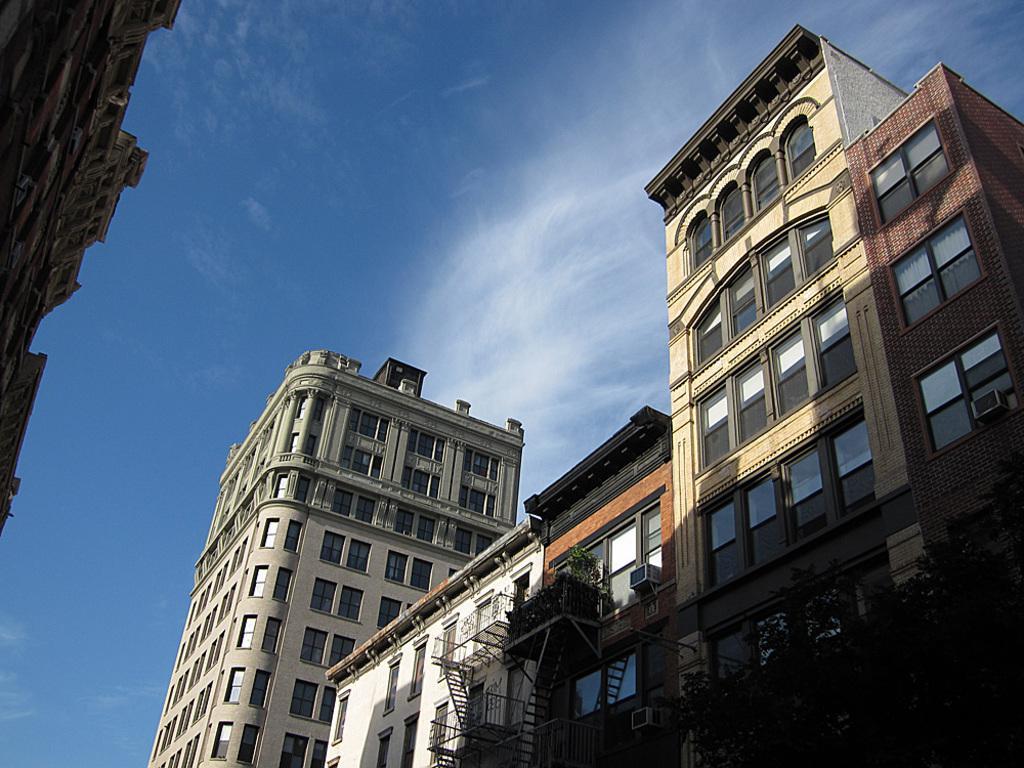Please provide a concise description of this image. Here we can see buildings, plants and trees. To these buildings there are glass windows. Background there is a sky. These are clouds.  